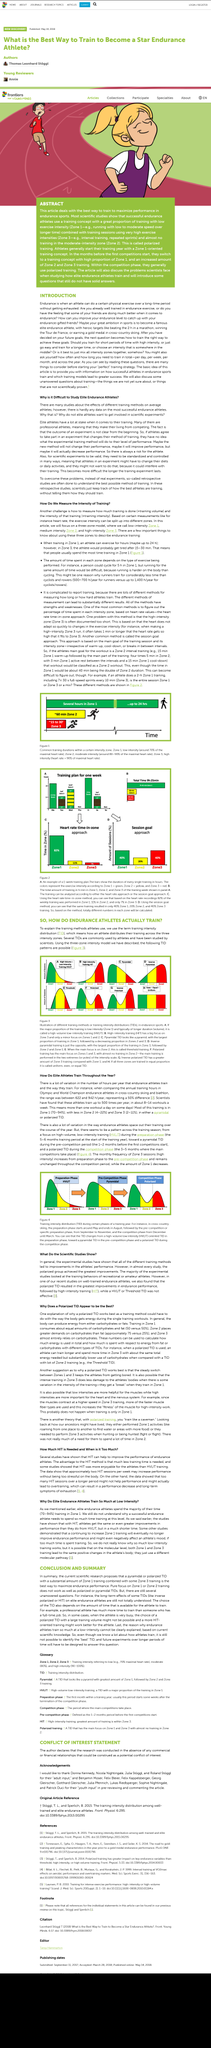Specify some key components in this picture. There are three intensity zones. The article is about scientific studies. Endurance athletes train an average of up to 500 times per year, depending on their level of competition and training regimen. The difference in training hours between Olympic athletes of Biathlon and cross-country skiing is 50%. The model uses three different zones. 